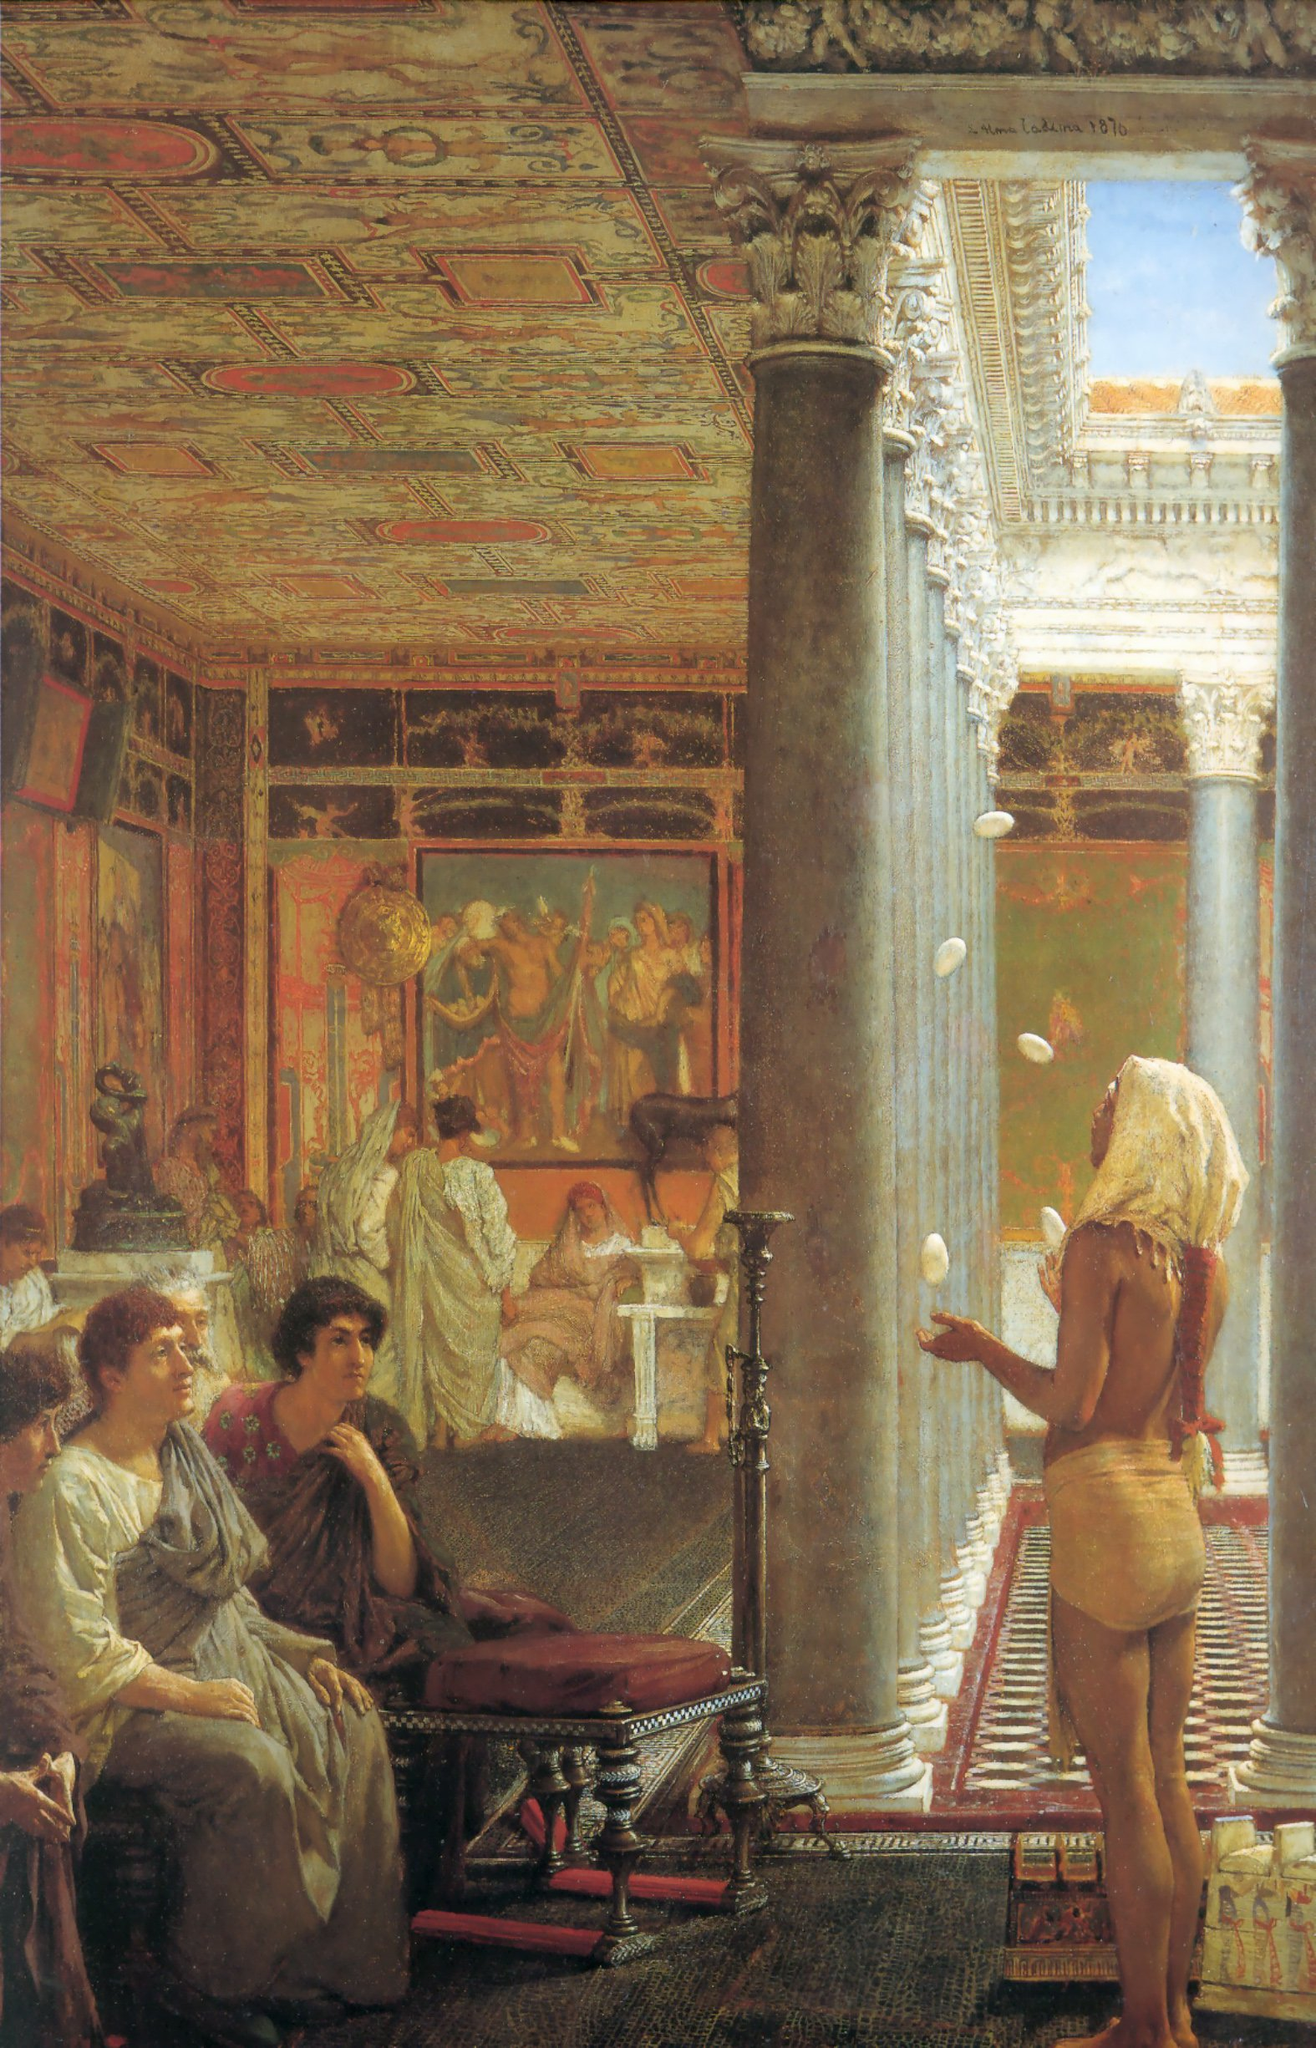What does the opulence of the room suggest about the social status of the people depicted? The extravagant details and opulence of the room suggest that the people depicted are of high social status or wealth. The luxurious architecture, with its high ceilings, ornate columns, and intricate decorations, indicates a space reserved for the elite. Additionally, the figures' attire – flowing robes and elaborately designed garments – further underscores their high rank and societal importance. The presence of expensive artwork and numerous classical sculptures also reflects a setting where art and culture are highly valued, typically associated with the affluent class. Create a creative story about an event happening in this room. In the heart of the grand hall, beneath the golden glow of an afternoon sun that streamed through colossal windows, a gathering like no other was unfolding. Empress Octavia, famed for her wisdom and grace, had invited the greatest minds of the empire for a symposium on the future of their civilization. As poets recited verses of yore and philosophers debated the cosmos' secrets, a juggler from distant lands dazzled the guests with his otherworldly skills, his movements a blur of precision and artistry. Among the audience, seated quietly, was a young artist sketching the scene, unaware that his creation would outlive them all and offer a glimpse into this vibrant moment for future generations. 